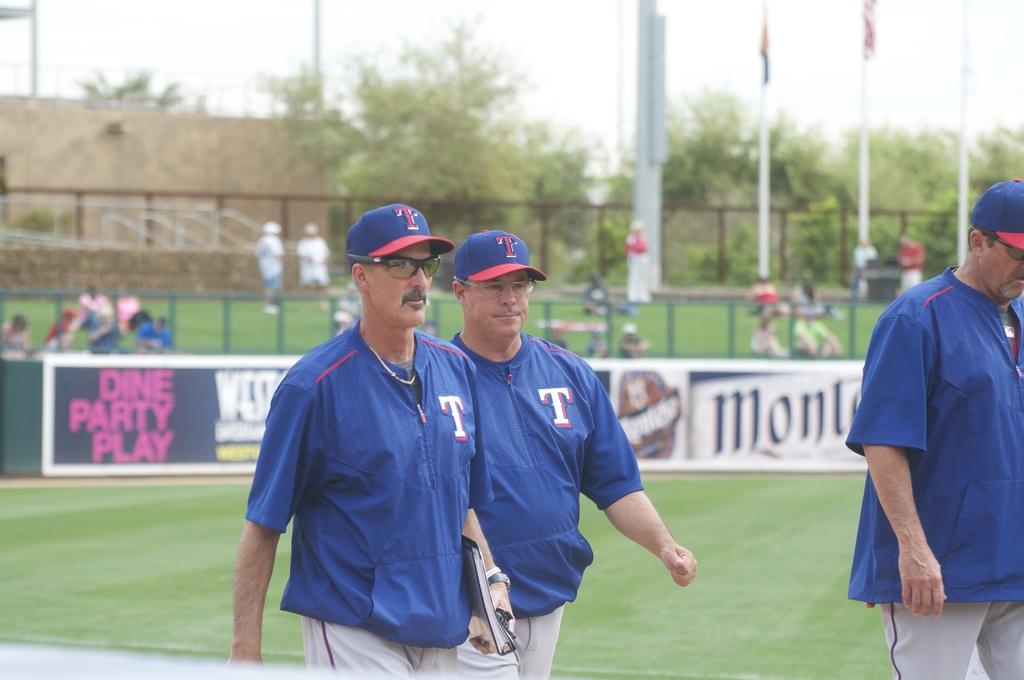What letter is on the man's shirt?
Keep it short and to the point. T. What is in pink text on the banner?
Offer a terse response. Dine party play. 